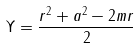Convert formula to latex. <formula><loc_0><loc_0><loc_500><loc_500>\Upsilon = \frac { r ^ { 2 } + a ^ { 2 } - 2 m r } { 2 }</formula> 